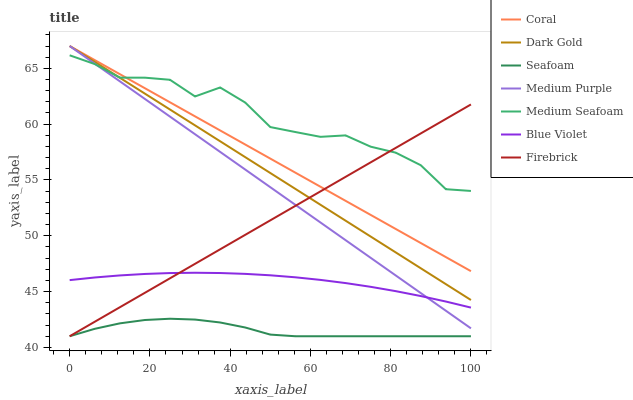Does Seafoam have the minimum area under the curve?
Answer yes or no. Yes. Does Medium Seafoam have the maximum area under the curve?
Answer yes or no. Yes. Does Coral have the minimum area under the curve?
Answer yes or no. No. Does Coral have the maximum area under the curve?
Answer yes or no. No. Is Coral the smoothest?
Answer yes or no. Yes. Is Medium Seafoam the roughest?
Answer yes or no. Yes. Is Seafoam the smoothest?
Answer yes or no. No. Is Seafoam the roughest?
Answer yes or no. No. Does Seafoam have the lowest value?
Answer yes or no. Yes. Does Coral have the lowest value?
Answer yes or no. No. Does Medium Purple have the highest value?
Answer yes or no. Yes. Does Seafoam have the highest value?
Answer yes or no. No. Is Seafoam less than Medium Purple?
Answer yes or no. Yes. Is Coral greater than Blue Violet?
Answer yes or no. Yes. Does Dark Gold intersect Medium Purple?
Answer yes or no. Yes. Is Dark Gold less than Medium Purple?
Answer yes or no. No. Is Dark Gold greater than Medium Purple?
Answer yes or no. No. Does Seafoam intersect Medium Purple?
Answer yes or no. No. 